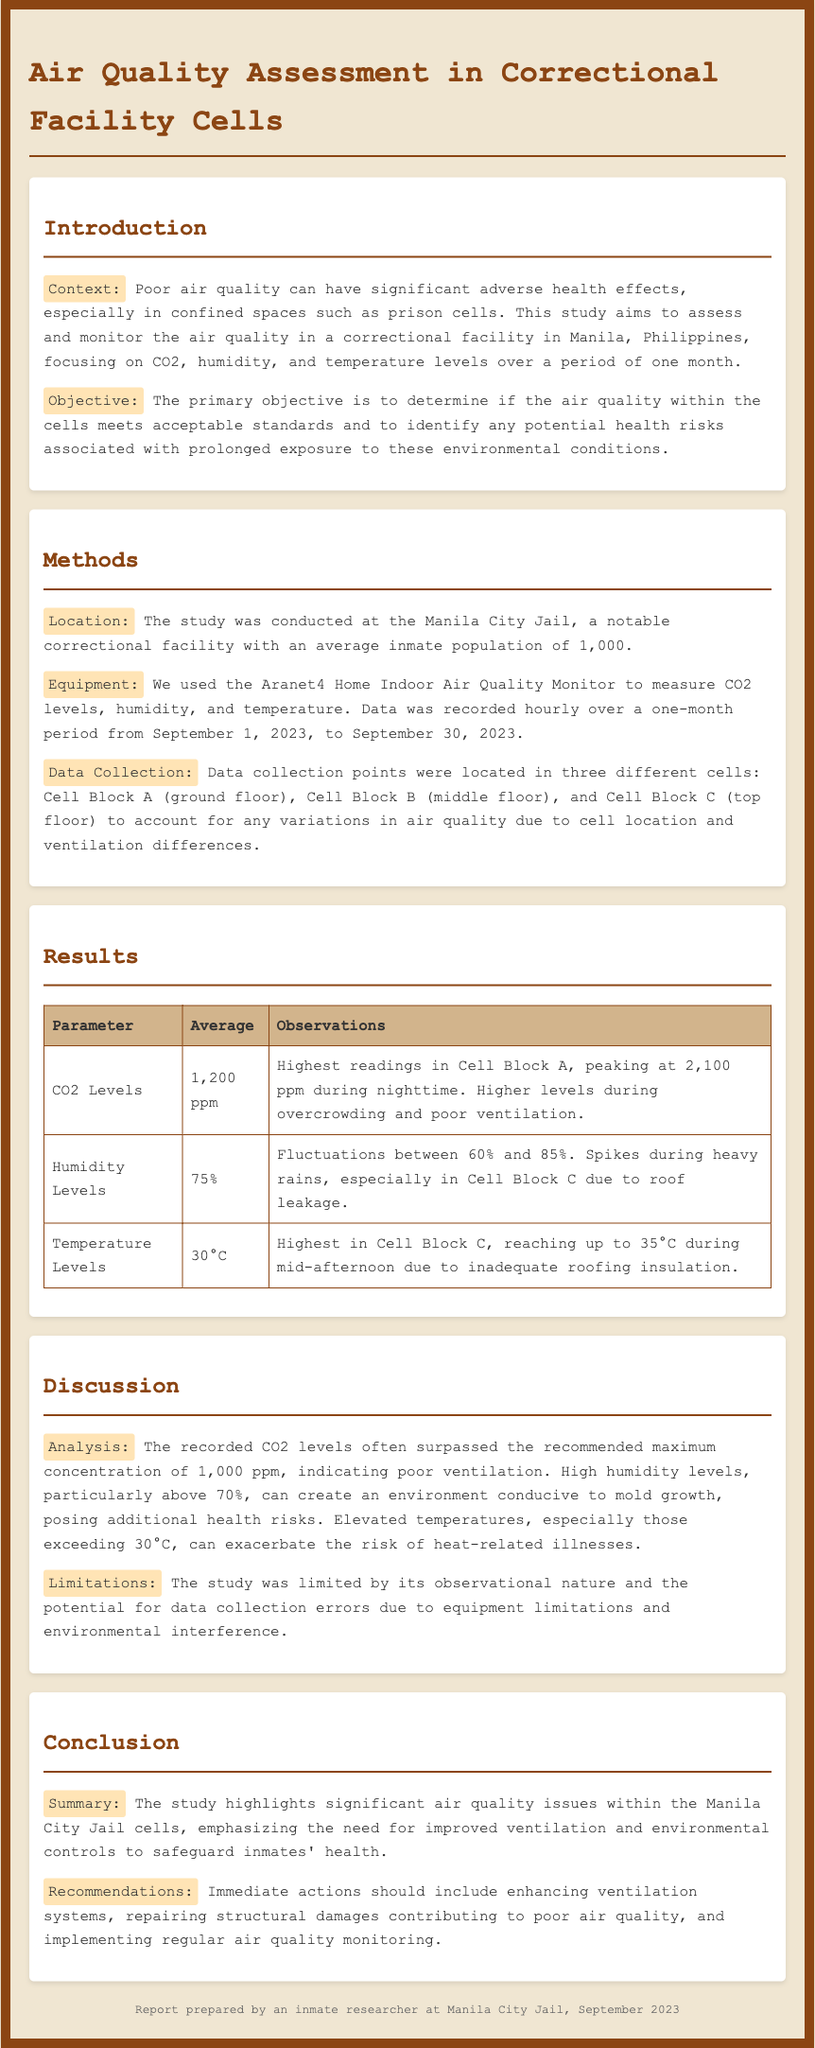What is the average CO2 level recorded? The average CO2 level is stated in the results section of the report as 1,200 ppm.
Answer: 1,200 ppm What is the humidity fluctuation range observed? The document mentions that humidity levels fluctuated between 60% and 85%.
Answer: 60% and 85% What is the maximum CO2 level recorded during the study? The report indicates that CO2 levels peaked at 2,100 ppm during nighttime.
Answer: 2,100 ppm Which cell block recorded the highest temperature? The report specifies that Cell Block C had the highest temperature levels.
Answer: Cell Block C What was the duration of the study? The introduction provides the start and end dates for data collection, which is from September 1 to September 30, 2023.
Answer: One month What recommendation is made regarding ventilation? The conclusion section emphasizes the need to enhance ventilation systems.
Answer: Enhance ventilation systems Why are high humidity levels a concern? The discussion points out that humidity levels above 70% can promote mold growth.
Answer: Mold growth What equipment was used for measuring air quality? The methods section details the use of the Aranet4 Home Indoor Air Quality Monitor for measurements.
Answer: Aranet4 Home Indoor Air Quality Monitor What are the observed temperature levels? The results indicate the average temperature level was 30°C.
Answer: 30°C 